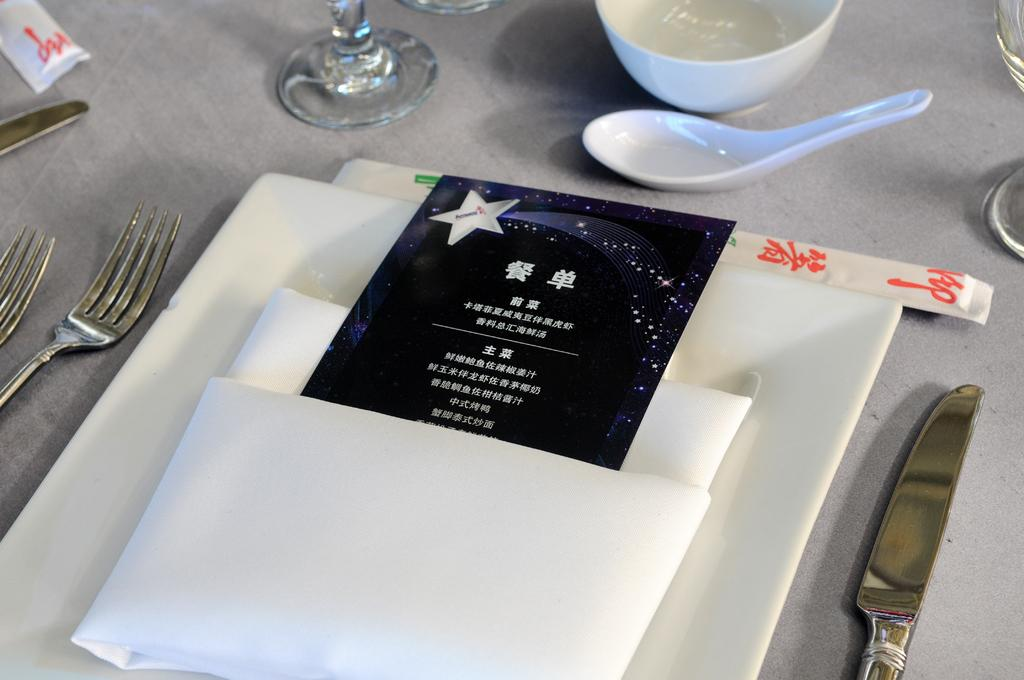What type of furniture is present in the image? There is a table in the image. What is covering the table? There is a cloth on the table. What utensils are on the table? There is a knife, a spoon, and a fork on the table. What type of dish is on the table? There is a bowl on the table. What type of reading material is on the table? There is a pamphlet on the table. How many men are playing cards on the table in the image? There are no men or cards present in the image; it only features a table with a cloth, utensils, a bowl, and a pamphlet. 